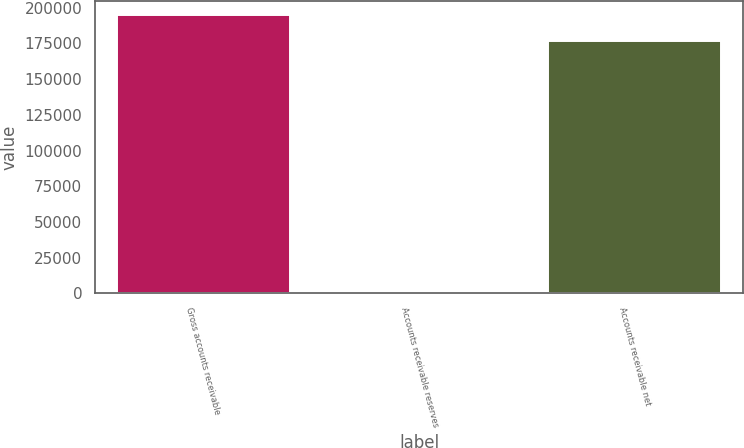<chart> <loc_0><loc_0><loc_500><loc_500><bar_chart><fcel>Gross accounts receivable<fcel>Accounts receivable reserves<fcel>Accounts receivable net<nl><fcel>194609<fcel>453<fcel>176917<nl></chart> 